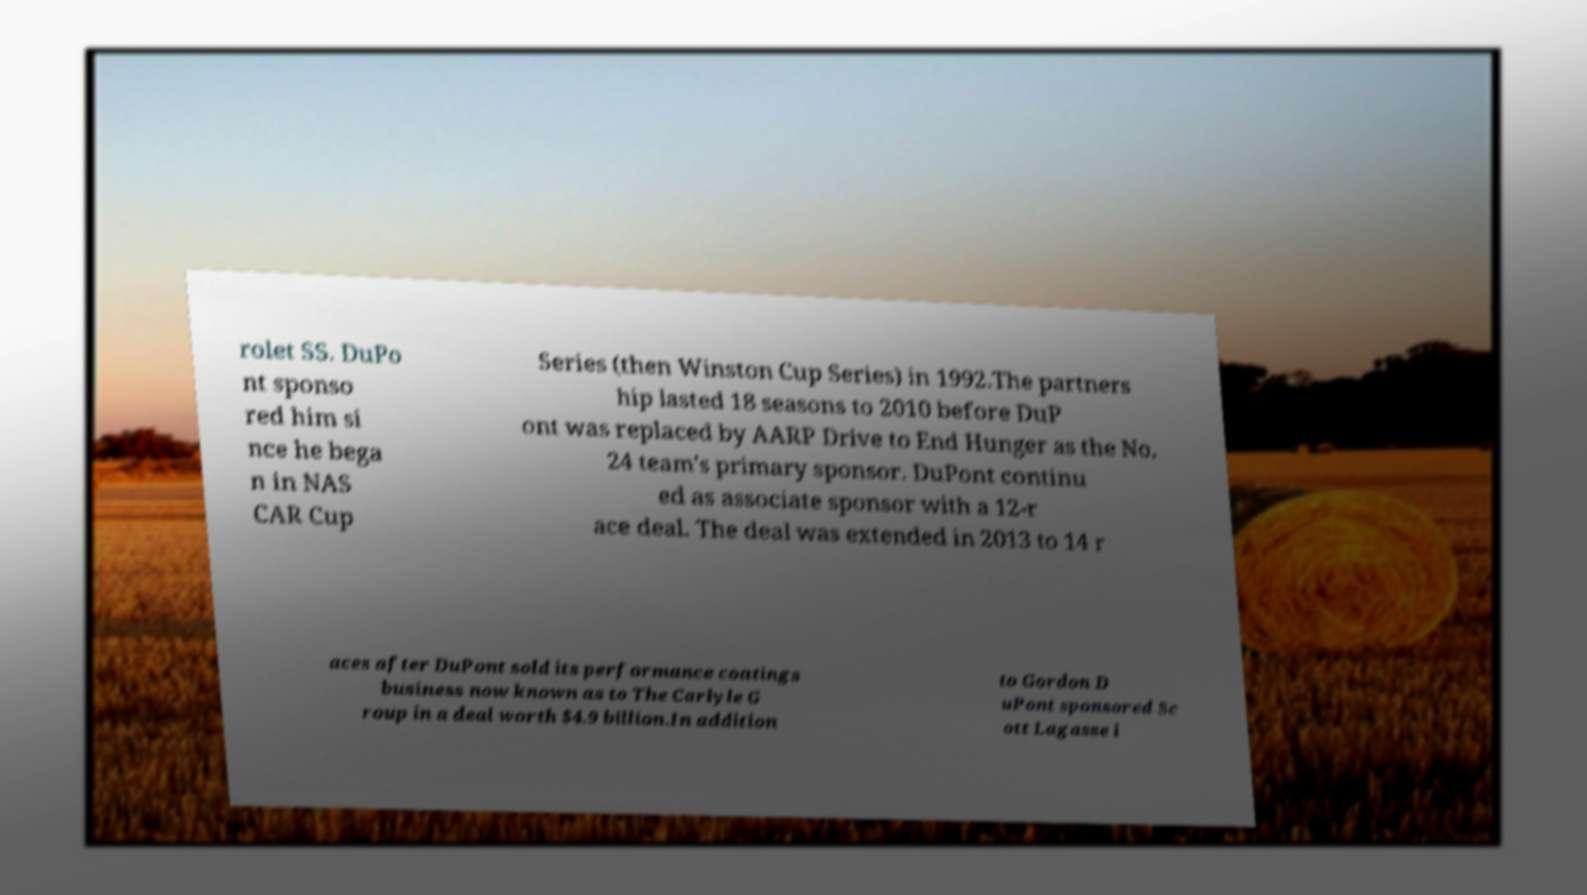Could you extract and type out the text from this image? rolet SS. DuPo nt sponso red him si nce he bega n in NAS CAR Cup Series (then Winston Cup Series) in 1992.The partners hip lasted 18 seasons to 2010 before DuP ont was replaced by AARP Drive to End Hunger as the No. 24 team's primary sponsor. DuPont continu ed as associate sponsor with a 12-r ace deal. The deal was extended in 2013 to 14 r aces after DuPont sold its performance coatings business now known as to The Carlyle G roup in a deal worth $4.9 billion.In addition to Gordon D uPont sponsored Sc ott Lagasse i 